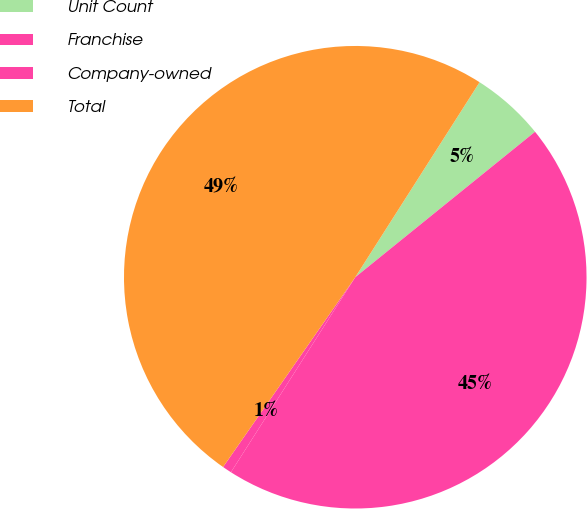<chart> <loc_0><loc_0><loc_500><loc_500><pie_chart><fcel>Unit Count<fcel>Franchise<fcel>Company-owned<fcel>Total<nl><fcel>5.14%<fcel>44.86%<fcel>0.65%<fcel>49.35%<nl></chart> 